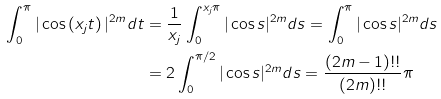Convert formula to latex. <formula><loc_0><loc_0><loc_500><loc_500>\int _ { 0 } ^ { \pi } | \cos \left ( x _ { j } t \right ) | ^ { 2 m } d t & = \frac { 1 } { x _ { j } } \int _ { 0 } ^ { x _ { j } \pi } | \cos s | ^ { 2 m } d s = \int _ { 0 } ^ { \pi } | \cos s | ^ { 2 m } d s \\ & = 2 \int _ { 0 } ^ { \pi / 2 } | \cos s | ^ { 2 m } d s = \frac { ( 2 m - 1 ) ! ! } { ( 2 m ) ! ! } \pi</formula> 